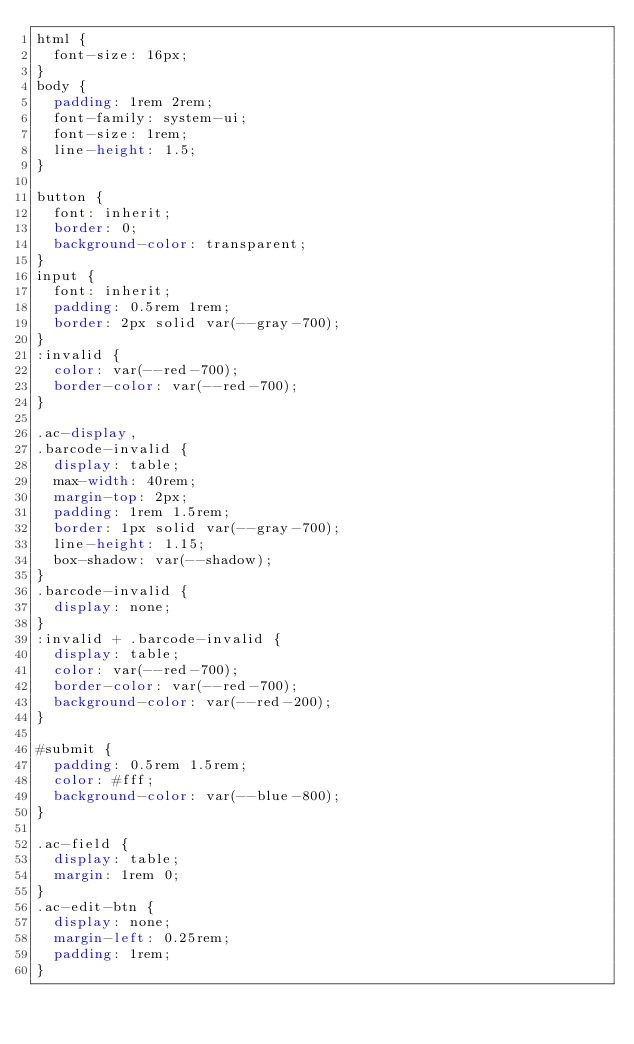Convert code to text. <code><loc_0><loc_0><loc_500><loc_500><_CSS_>html {
  font-size: 16px;
}
body {
  padding: 1rem 2rem;
  font-family: system-ui;
  font-size: 1rem;
  line-height: 1.5;
}

button {
  font: inherit;
  border: 0;
  background-color: transparent;
}
input {
  font: inherit;
  padding: 0.5rem 1rem;
  border: 2px solid var(--gray-700);
}
:invalid {
  color: var(--red-700);
  border-color: var(--red-700);
}

.ac-display,
.barcode-invalid {
  display: table;
  max-width: 40rem;
  margin-top: 2px;
  padding: 1rem 1.5rem;
  border: 1px solid var(--gray-700);
  line-height: 1.15;
  box-shadow: var(--shadow);
}
.barcode-invalid {
  display: none;
}
:invalid + .barcode-invalid {
  display: table;
  color: var(--red-700);
  border-color: var(--red-700);
  background-color: var(--red-200);
}

#submit {
  padding: 0.5rem 1.5rem;
  color: #fff;
  background-color: var(--blue-800);
}

.ac-field {
  display: table;
  margin: 1rem 0;
}
.ac-edit-btn {
  display: none;
  margin-left: 0.25rem;
  padding: 1rem;
}</code> 